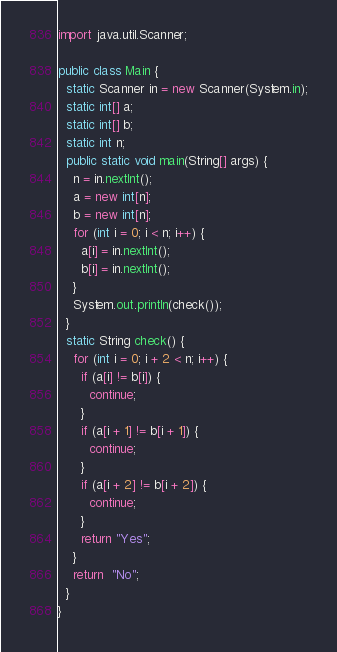<code> <loc_0><loc_0><loc_500><loc_500><_Java_>import java.util.Scanner;

public class Main {
  static Scanner in = new Scanner(System.in);
  static int[] a;
  static int[] b;
  static int n;
  public static void main(String[] args) {
    n = in.nextInt();
    a = new int[n];
    b = new int[n];
    for (int i = 0; i < n; i++) {
      a[i] = in.nextInt();
      b[i] = in.nextInt();
    }
    System.out.println(check());
  }
  static String check() {
    for (int i = 0; i + 2 < n; i++) {
      if (a[i] != b[i]) {
        continue;
      }
      if (a[i + 1] != b[i + 1]) {
        continue;
      }
      if (a[i + 2] != b[i + 2]) {
        continue;
      }
      return "Yes";
    }
    return  "No";
  }
}
</code> 